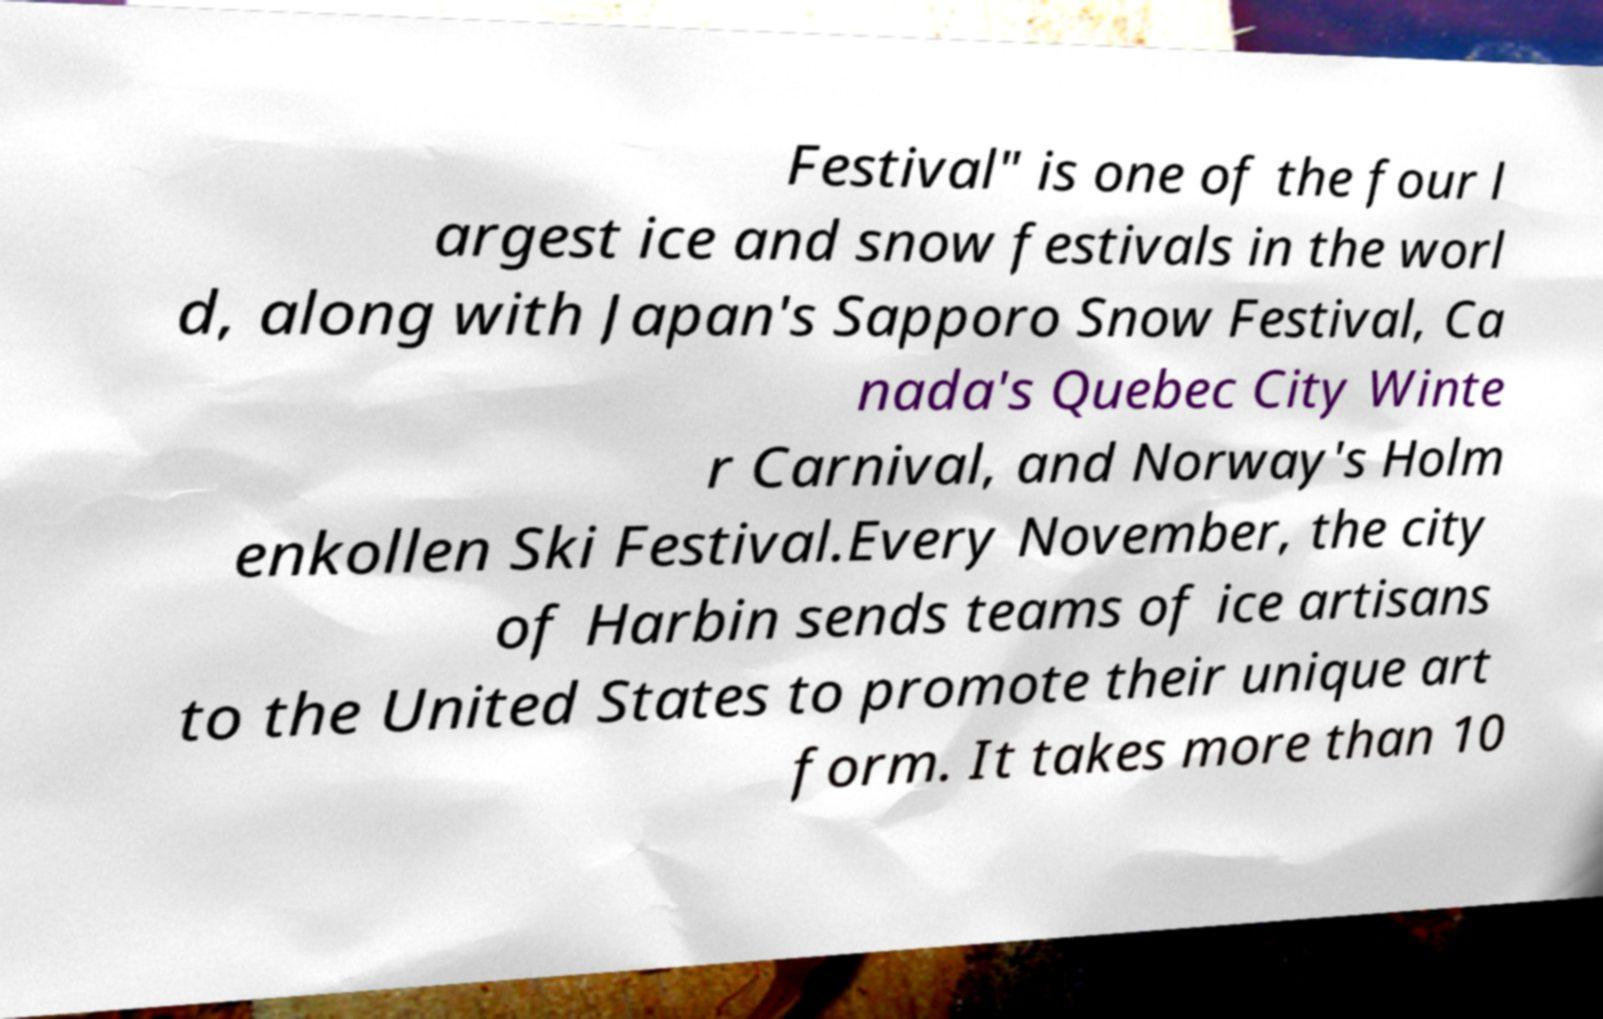For documentation purposes, I need the text within this image transcribed. Could you provide that? Festival" is one of the four l argest ice and snow festivals in the worl d, along with Japan's Sapporo Snow Festival, Ca nada's Quebec City Winte r Carnival, and Norway's Holm enkollen Ski Festival.Every November, the city of Harbin sends teams of ice artisans to the United States to promote their unique art form. It takes more than 10 